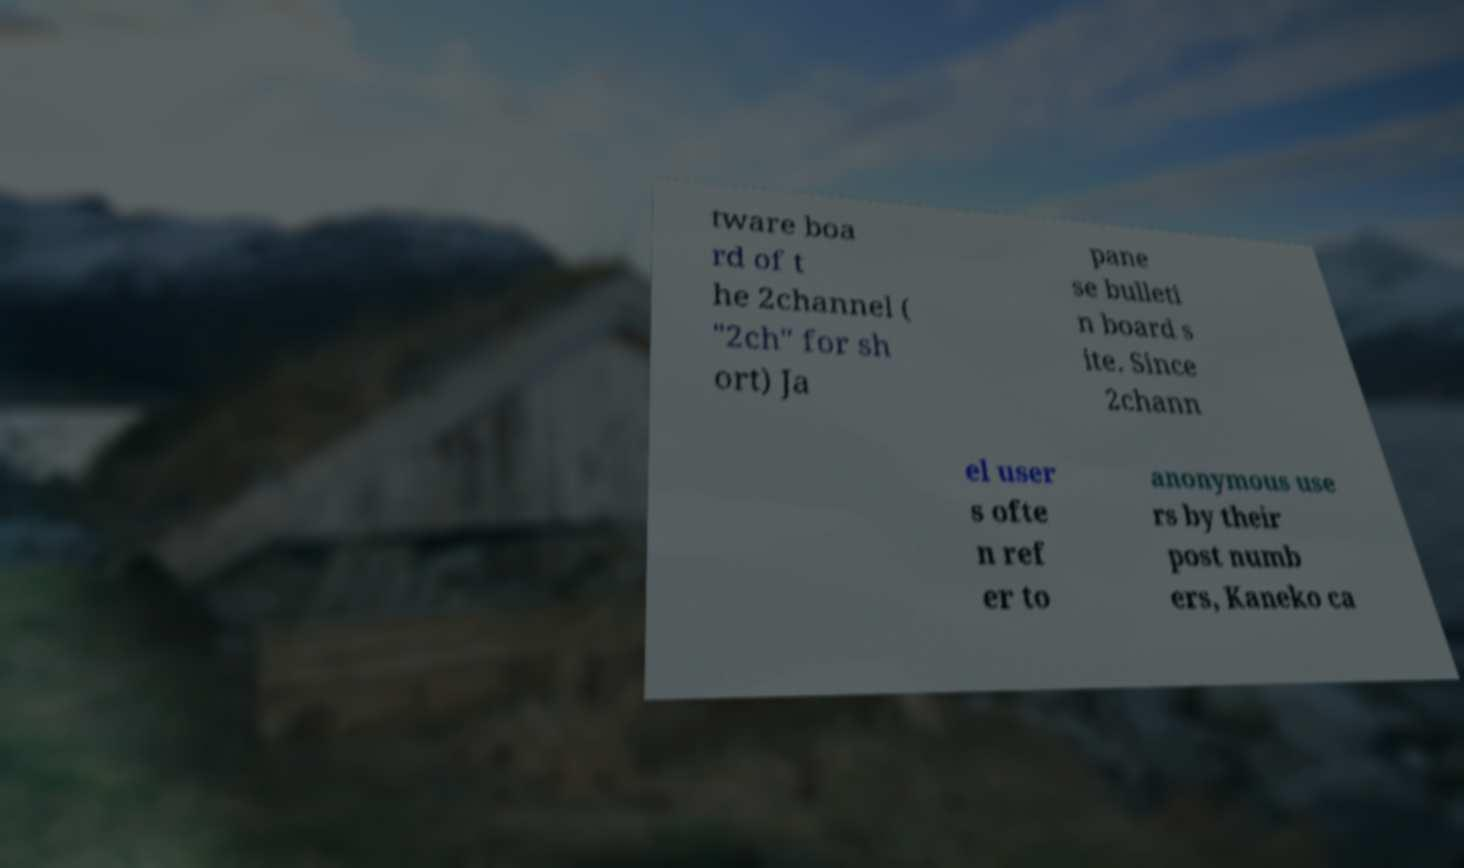Could you assist in decoding the text presented in this image and type it out clearly? tware boa rd of t he 2channel ( "2ch" for sh ort) Ja pane se bulleti n board s ite. Since 2chann el user s ofte n ref er to anonymous use rs by their post numb ers, Kaneko ca 